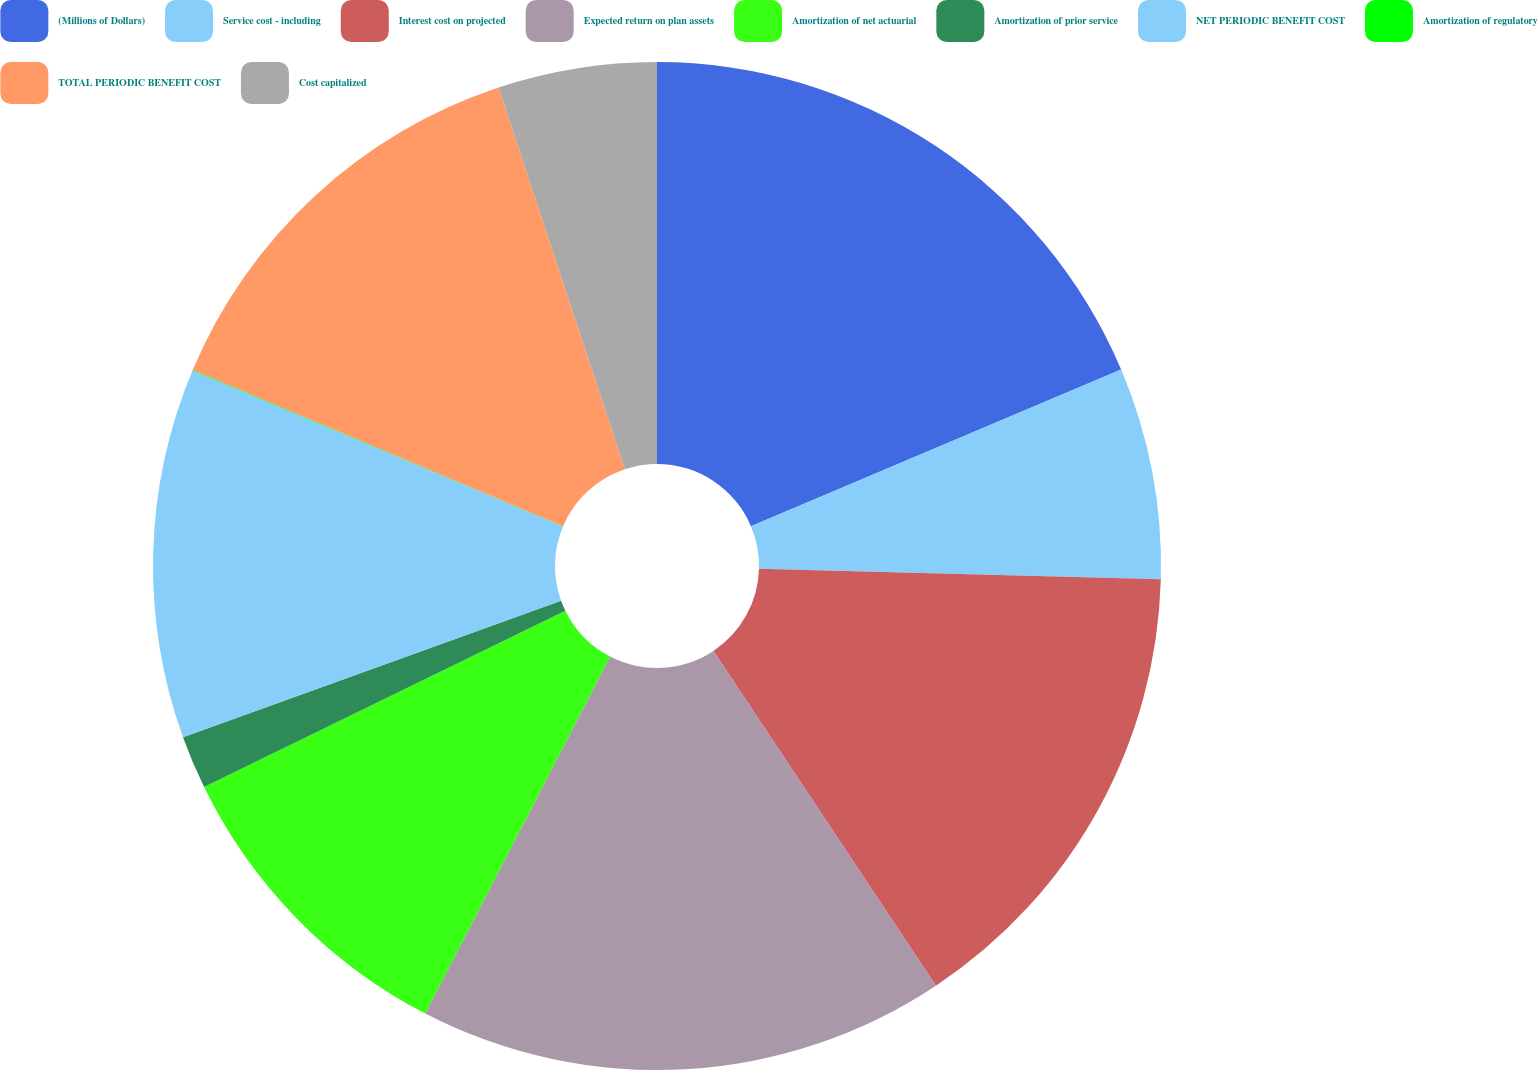Convert chart to OTSL. <chart><loc_0><loc_0><loc_500><loc_500><pie_chart><fcel>(Millions of Dollars)<fcel>Service cost - including<fcel>Interest cost on projected<fcel>Expected return on plan assets<fcel>Amortization of net actuarial<fcel>Amortization of prior service<fcel>NET PERIODIC BENEFIT COST<fcel>Amortization of regulatory<fcel>TOTAL PERIODIC BENEFIT COST<fcel>Cost capitalized<nl><fcel>18.63%<fcel>6.79%<fcel>15.25%<fcel>16.94%<fcel>10.17%<fcel>1.71%<fcel>11.86%<fcel>0.02%<fcel>13.55%<fcel>5.09%<nl></chart> 